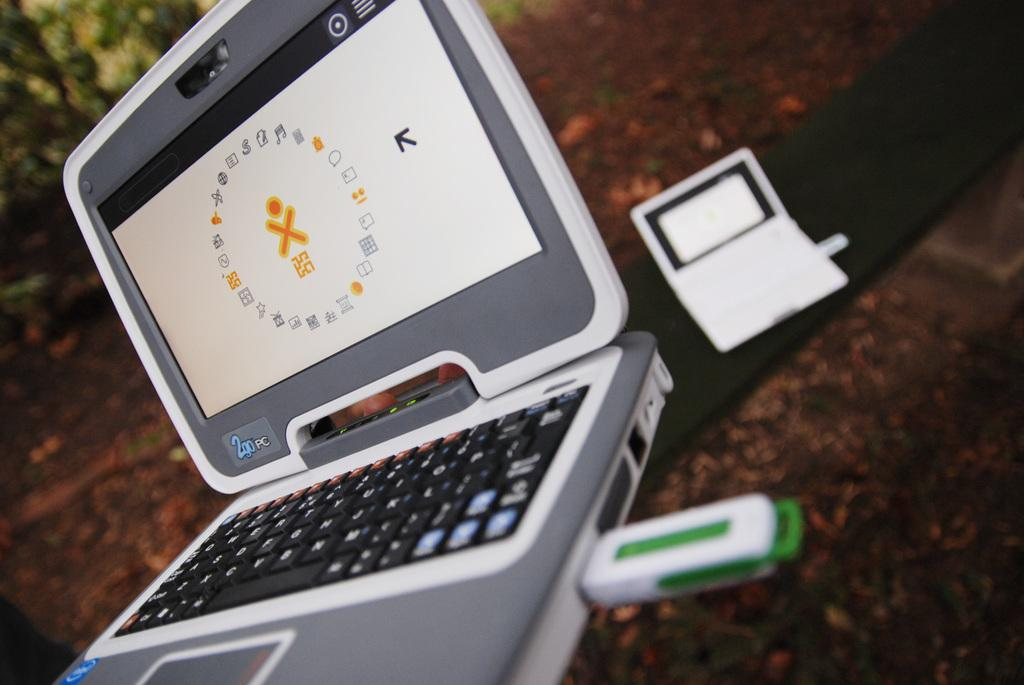<image>
Share a concise interpretation of the image provided. A lap top that is open and says 2 go PC on it. 